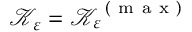<formula> <loc_0><loc_0><loc_500><loc_500>\mathcal { K } _ { \varepsilon } = \mathcal { K } _ { \varepsilon } ^ { ( m a x ) }</formula> 